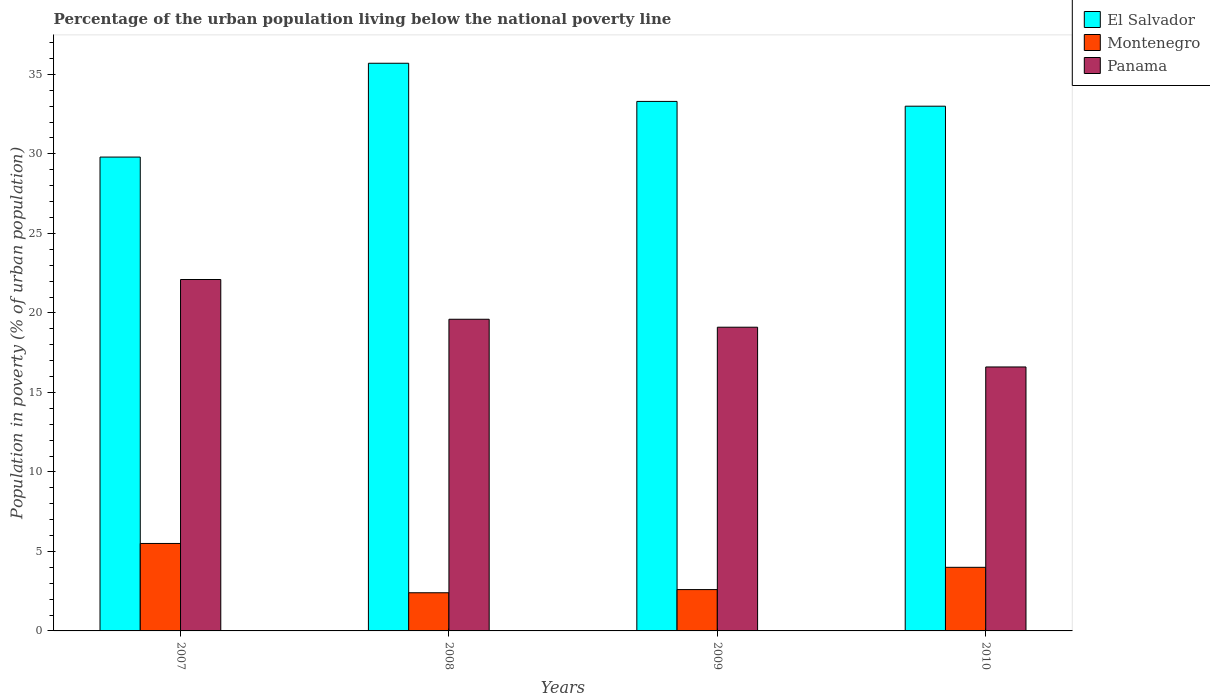How many groups of bars are there?
Your answer should be compact. 4. Are the number of bars on each tick of the X-axis equal?
Offer a terse response. Yes. How many bars are there on the 1st tick from the left?
Provide a short and direct response. 3. What is the label of the 4th group of bars from the left?
Make the answer very short. 2010. What is the percentage of the urban population living below the national poverty line in Panama in 2007?
Ensure brevity in your answer.  22.1. Across all years, what is the maximum percentage of the urban population living below the national poverty line in Montenegro?
Give a very brief answer. 5.5. Across all years, what is the minimum percentage of the urban population living below the national poverty line in El Salvador?
Offer a very short reply. 29.8. In which year was the percentage of the urban population living below the national poverty line in Panama minimum?
Offer a very short reply. 2010. What is the total percentage of the urban population living below the national poverty line in El Salvador in the graph?
Your answer should be compact. 131.8. What is the average percentage of the urban population living below the national poverty line in El Salvador per year?
Ensure brevity in your answer.  32.95. In the year 2008, what is the difference between the percentage of the urban population living below the national poverty line in Panama and percentage of the urban population living below the national poverty line in El Salvador?
Your response must be concise. -16.1. What is the ratio of the percentage of the urban population living below the national poverty line in El Salvador in 2007 to that in 2010?
Offer a very short reply. 0.9. What is the difference between the highest and the second highest percentage of the urban population living below the national poverty line in Panama?
Offer a very short reply. 2.5. What is the difference between the highest and the lowest percentage of the urban population living below the national poverty line in Montenegro?
Make the answer very short. 3.1. In how many years, is the percentage of the urban population living below the national poverty line in Montenegro greater than the average percentage of the urban population living below the national poverty line in Montenegro taken over all years?
Your response must be concise. 2. Is the sum of the percentage of the urban population living below the national poverty line in Panama in 2007 and 2010 greater than the maximum percentage of the urban population living below the national poverty line in El Salvador across all years?
Make the answer very short. Yes. What does the 2nd bar from the left in 2010 represents?
Provide a short and direct response. Montenegro. What does the 2nd bar from the right in 2010 represents?
Your answer should be very brief. Montenegro. How many years are there in the graph?
Ensure brevity in your answer.  4. Does the graph contain any zero values?
Make the answer very short. No. How are the legend labels stacked?
Provide a short and direct response. Vertical. What is the title of the graph?
Your answer should be very brief. Percentage of the urban population living below the national poverty line. Does "Ethiopia" appear as one of the legend labels in the graph?
Provide a succinct answer. No. What is the label or title of the X-axis?
Offer a very short reply. Years. What is the label or title of the Y-axis?
Ensure brevity in your answer.  Population in poverty (% of urban population). What is the Population in poverty (% of urban population) in El Salvador in 2007?
Provide a short and direct response. 29.8. What is the Population in poverty (% of urban population) in Panama in 2007?
Give a very brief answer. 22.1. What is the Population in poverty (% of urban population) of El Salvador in 2008?
Provide a succinct answer. 35.7. What is the Population in poverty (% of urban population) in Panama in 2008?
Make the answer very short. 19.6. What is the Population in poverty (% of urban population) of El Salvador in 2009?
Ensure brevity in your answer.  33.3. What is the Population in poverty (% of urban population) of Montenegro in 2010?
Keep it short and to the point. 4. What is the Population in poverty (% of urban population) of Panama in 2010?
Your response must be concise. 16.6. Across all years, what is the maximum Population in poverty (% of urban population) in El Salvador?
Give a very brief answer. 35.7. Across all years, what is the maximum Population in poverty (% of urban population) of Panama?
Keep it short and to the point. 22.1. Across all years, what is the minimum Population in poverty (% of urban population) of El Salvador?
Make the answer very short. 29.8. What is the total Population in poverty (% of urban population) in El Salvador in the graph?
Keep it short and to the point. 131.8. What is the total Population in poverty (% of urban population) of Montenegro in the graph?
Keep it short and to the point. 14.5. What is the total Population in poverty (% of urban population) of Panama in the graph?
Give a very brief answer. 77.4. What is the difference between the Population in poverty (% of urban population) in Panama in 2007 and that in 2008?
Make the answer very short. 2.5. What is the difference between the Population in poverty (% of urban population) of El Salvador in 2007 and that in 2009?
Provide a short and direct response. -3.5. What is the difference between the Population in poverty (% of urban population) of Montenegro in 2007 and that in 2009?
Provide a succinct answer. 2.9. What is the difference between the Population in poverty (% of urban population) of El Salvador in 2007 and that in 2010?
Give a very brief answer. -3.2. What is the difference between the Population in poverty (% of urban population) in Montenegro in 2007 and that in 2010?
Offer a very short reply. 1.5. What is the difference between the Population in poverty (% of urban population) of Panama in 2007 and that in 2010?
Keep it short and to the point. 5.5. What is the difference between the Population in poverty (% of urban population) in El Salvador in 2008 and that in 2009?
Your answer should be very brief. 2.4. What is the difference between the Population in poverty (% of urban population) of Montenegro in 2008 and that in 2009?
Your answer should be very brief. -0.2. What is the difference between the Population in poverty (% of urban population) of Panama in 2008 and that in 2009?
Ensure brevity in your answer.  0.5. What is the difference between the Population in poverty (% of urban population) in El Salvador in 2008 and that in 2010?
Keep it short and to the point. 2.7. What is the difference between the Population in poverty (% of urban population) in El Salvador in 2009 and that in 2010?
Your response must be concise. 0.3. What is the difference between the Population in poverty (% of urban population) of El Salvador in 2007 and the Population in poverty (% of urban population) of Montenegro in 2008?
Your answer should be compact. 27.4. What is the difference between the Population in poverty (% of urban population) of Montenegro in 2007 and the Population in poverty (% of urban population) of Panama in 2008?
Offer a very short reply. -14.1. What is the difference between the Population in poverty (% of urban population) of El Salvador in 2007 and the Population in poverty (% of urban population) of Montenegro in 2009?
Your answer should be very brief. 27.2. What is the difference between the Population in poverty (% of urban population) in Montenegro in 2007 and the Population in poverty (% of urban population) in Panama in 2009?
Your answer should be compact. -13.6. What is the difference between the Population in poverty (% of urban population) of El Salvador in 2007 and the Population in poverty (% of urban population) of Montenegro in 2010?
Your answer should be very brief. 25.8. What is the difference between the Population in poverty (% of urban population) in Montenegro in 2007 and the Population in poverty (% of urban population) in Panama in 2010?
Give a very brief answer. -11.1. What is the difference between the Population in poverty (% of urban population) of El Salvador in 2008 and the Population in poverty (% of urban population) of Montenegro in 2009?
Make the answer very short. 33.1. What is the difference between the Population in poverty (% of urban population) of El Salvador in 2008 and the Population in poverty (% of urban population) of Panama in 2009?
Your answer should be very brief. 16.6. What is the difference between the Population in poverty (% of urban population) of Montenegro in 2008 and the Population in poverty (% of urban population) of Panama in 2009?
Ensure brevity in your answer.  -16.7. What is the difference between the Population in poverty (% of urban population) of El Salvador in 2008 and the Population in poverty (% of urban population) of Montenegro in 2010?
Offer a very short reply. 31.7. What is the difference between the Population in poverty (% of urban population) of El Salvador in 2008 and the Population in poverty (% of urban population) of Panama in 2010?
Keep it short and to the point. 19.1. What is the difference between the Population in poverty (% of urban population) of Montenegro in 2008 and the Population in poverty (% of urban population) of Panama in 2010?
Ensure brevity in your answer.  -14.2. What is the difference between the Population in poverty (% of urban population) of El Salvador in 2009 and the Population in poverty (% of urban population) of Montenegro in 2010?
Offer a terse response. 29.3. What is the average Population in poverty (% of urban population) of El Salvador per year?
Your answer should be compact. 32.95. What is the average Population in poverty (% of urban population) in Montenegro per year?
Offer a very short reply. 3.62. What is the average Population in poverty (% of urban population) of Panama per year?
Offer a terse response. 19.35. In the year 2007, what is the difference between the Population in poverty (% of urban population) of El Salvador and Population in poverty (% of urban population) of Montenegro?
Your response must be concise. 24.3. In the year 2007, what is the difference between the Population in poverty (% of urban population) of Montenegro and Population in poverty (% of urban population) of Panama?
Offer a terse response. -16.6. In the year 2008, what is the difference between the Population in poverty (% of urban population) of El Salvador and Population in poverty (% of urban population) of Montenegro?
Your answer should be compact. 33.3. In the year 2008, what is the difference between the Population in poverty (% of urban population) in Montenegro and Population in poverty (% of urban population) in Panama?
Your answer should be very brief. -17.2. In the year 2009, what is the difference between the Population in poverty (% of urban population) in El Salvador and Population in poverty (% of urban population) in Montenegro?
Your answer should be very brief. 30.7. In the year 2009, what is the difference between the Population in poverty (% of urban population) of El Salvador and Population in poverty (% of urban population) of Panama?
Give a very brief answer. 14.2. In the year 2009, what is the difference between the Population in poverty (% of urban population) of Montenegro and Population in poverty (% of urban population) of Panama?
Give a very brief answer. -16.5. In the year 2010, what is the difference between the Population in poverty (% of urban population) in El Salvador and Population in poverty (% of urban population) in Montenegro?
Provide a short and direct response. 29. In the year 2010, what is the difference between the Population in poverty (% of urban population) in El Salvador and Population in poverty (% of urban population) in Panama?
Your response must be concise. 16.4. In the year 2010, what is the difference between the Population in poverty (% of urban population) in Montenegro and Population in poverty (% of urban population) in Panama?
Provide a short and direct response. -12.6. What is the ratio of the Population in poverty (% of urban population) in El Salvador in 2007 to that in 2008?
Your answer should be compact. 0.83. What is the ratio of the Population in poverty (% of urban population) of Montenegro in 2007 to that in 2008?
Provide a short and direct response. 2.29. What is the ratio of the Population in poverty (% of urban population) in Panama in 2007 to that in 2008?
Give a very brief answer. 1.13. What is the ratio of the Population in poverty (% of urban population) of El Salvador in 2007 to that in 2009?
Offer a very short reply. 0.89. What is the ratio of the Population in poverty (% of urban population) of Montenegro in 2007 to that in 2009?
Make the answer very short. 2.12. What is the ratio of the Population in poverty (% of urban population) in Panama in 2007 to that in 2009?
Make the answer very short. 1.16. What is the ratio of the Population in poverty (% of urban population) in El Salvador in 2007 to that in 2010?
Your response must be concise. 0.9. What is the ratio of the Population in poverty (% of urban population) of Montenegro in 2007 to that in 2010?
Provide a succinct answer. 1.38. What is the ratio of the Population in poverty (% of urban population) of Panama in 2007 to that in 2010?
Your answer should be very brief. 1.33. What is the ratio of the Population in poverty (% of urban population) in El Salvador in 2008 to that in 2009?
Your response must be concise. 1.07. What is the ratio of the Population in poverty (% of urban population) of Panama in 2008 to that in 2009?
Offer a very short reply. 1.03. What is the ratio of the Population in poverty (% of urban population) in El Salvador in 2008 to that in 2010?
Provide a short and direct response. 1.08. What is the ratio of the Population in poverty (% of urban population) of Montenegro in 2008 to that in 2010?
Offer a very short reply. 0.6. What is the ratio of the Population in poverty (% of urban population) in Panama in 2008 to that in 2010?
Make the answer very short. 1.18. What is the ratio of the Population in poverty (% of urban population) of El Salvador in 2009 to that in 2010?
Provide a short and direct response. 1.01. What is the ratio of the Population in poverty (% of urban population) of Montenegro in 2009 to that in 2010?
Offer a terse response. 0.65. What is the ratio of the Population in poverty (% of urban population) in Panama in 2009 to that in 2010?
Provide a succinct answer. 1.15. What is the difference between the highest and the second highest Population in poverty (% of urban population) of El Salvador?
Keep it short and to the point. 2.4. What is the difference between the highest and the second highest Population in poverty (% of urban population) in Montenegro?
Make the answer very short. 1.5. What is the difference between the highest and the lowest Population in poverty (% of urban population) of El Salvador?
Keep it short and to the point. 5.9. What is the difference between the highest and the lowest Population in poverty (% of urban population) of Montenegro?
Keep it short and to the point. 3.1. What is the difference between the highest and the lowest Population in poverty (% of urban population) of Panama?
Offer a very short reply. 5.5. 